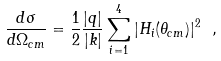Convert formula to latex. <formula><loc_0><loc_0><loc_500><loc_500>\frac { d \sigma } { d \Omega _ { c m } } = \frac { 1 } { 2 } \frac { | { q } | } { | { k } | } \sum _ { i = 1 } ^ { 4 } | H _ { i } ( \theta _ { c m } ) | ^ { 2 } \ ,</formula> 